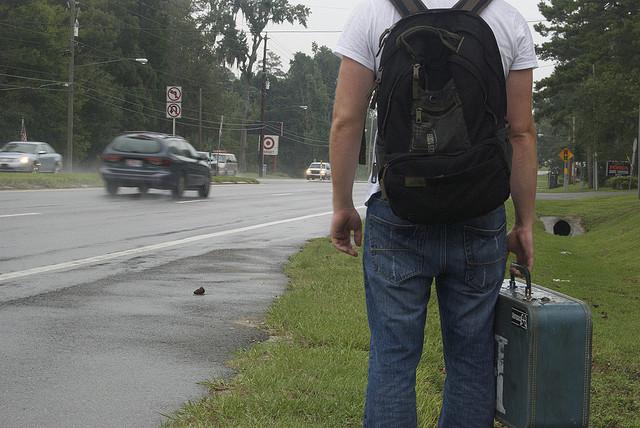Is this man hitchhiking?
Be succinct. Yes. How many red luggages are there?
Answer briefly. 0. Is this man homeless?
Concise answer only. No. What color is the backpack?
Keep it brief. Black. Was it raining earlier?
Write a very short answer. Yes. How many cars do you see?
Give a very brief answer. 4. 